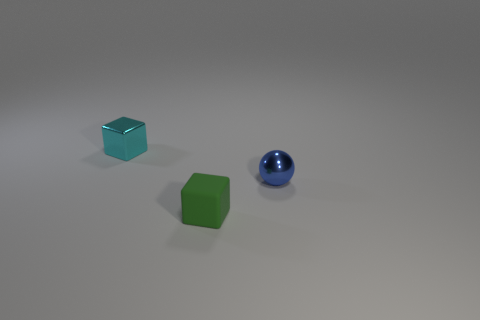What number of other objects are the same color as the tiny rubber cube?
Ensure brevity in your answer.  0. Do the metal ball and the green block have the same size?
Ensure brevity in your answer.  Yes. What is the color of the small shiny thing in front of the small object behind the tiny blue object?
Your response must be concise. Blue. What is the color of the tiny shiny sphere?
Make the answer very short. Blue. Is there a small thing of the same color as the shiny sphere?
Ensure brevity in your answer.  No. There is a object that is on the left side of the small green rubber thing; is it the same color as the tiny shiny sphere?
Offer a very short reply. No. How many objects are tiny shiny objects in front of the cyan object or cyan cylinders?
Provide a succinct answer. 1. Are there any green rubber things behind the tiny cyan metal block?
Provide a short and direct response. No. Are the tiny block that is behind the blue thing and the green block made of the same material?
Provide a short and direct response. No. Is there a cyan metal block behind the small blue shiny sphere that is behind the small cube that is right of the tiny cyan thing?
Provide a short and direct response. Yes. 